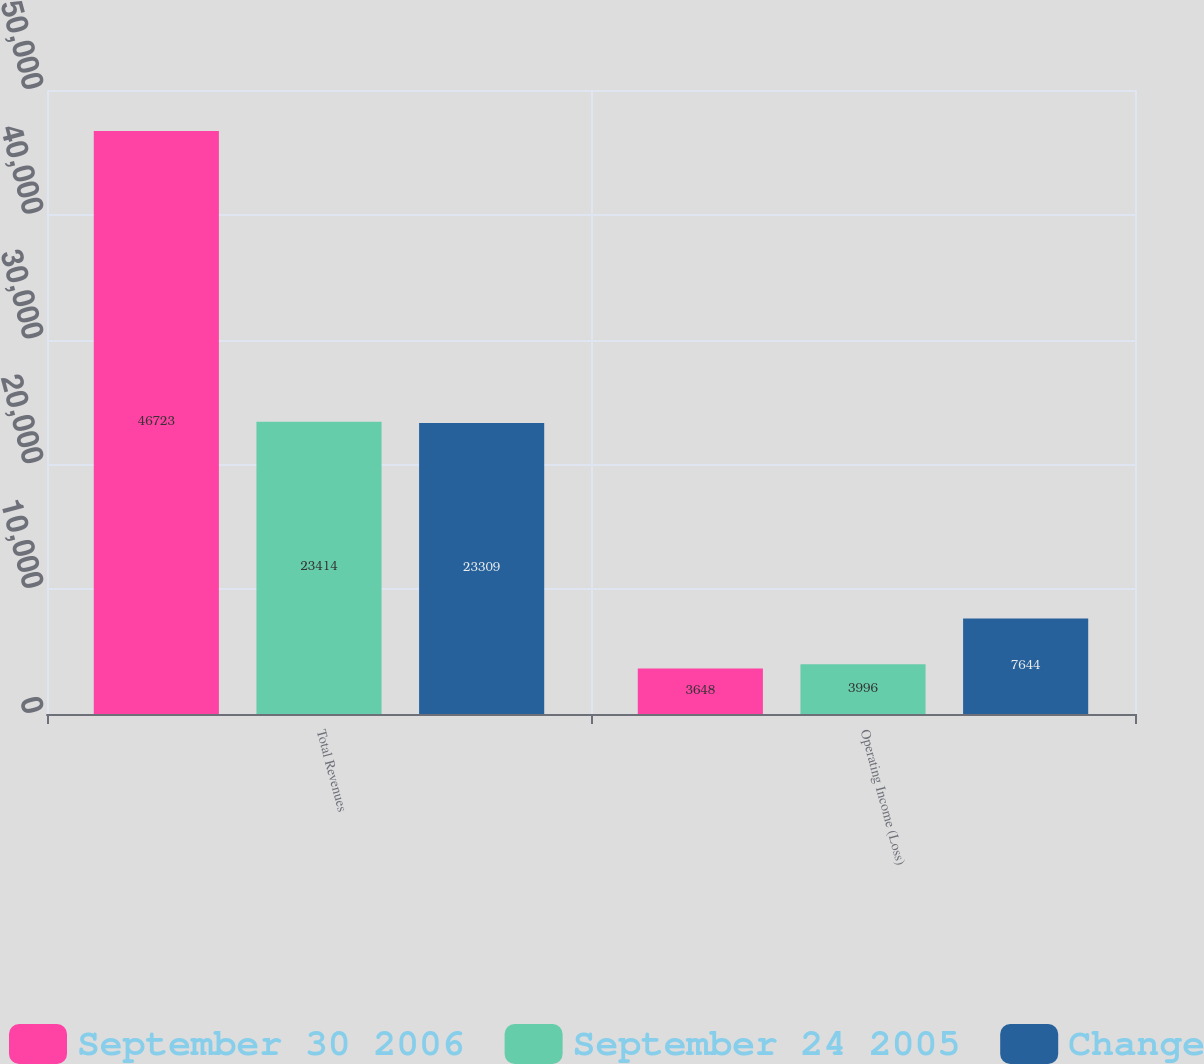Convert chart. <chart><loc_0><loc_0><loc_500><loc_500><stacked_bar_chart><ecel><fcel>Total Revenues<fcel>Operating Income (Loss)<nl><fcel>September 30 2006<fcel>46723<fcel>3648<nl><fcel>September 24 2005<fcel>23414<fcel>3996<nl><fcel>Change<fcel>23309<fcel>7644<nl></chart> 